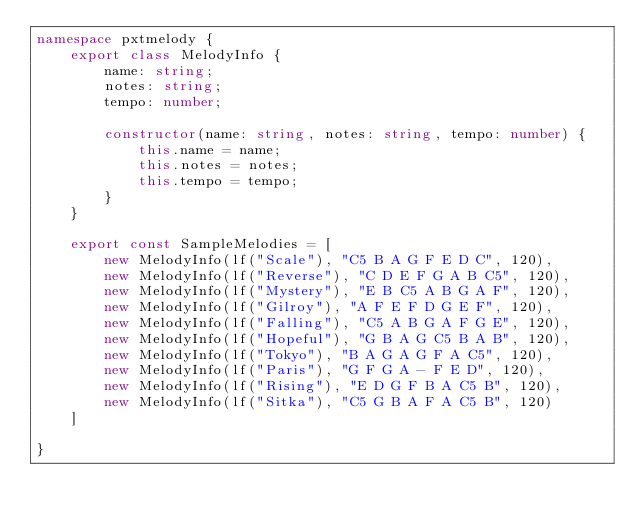<code> <loc_0><loc_0><loc_500><loc_500><_TypeScript_>namespace pxtmelody {
    export class MelodyInfo {
        name: string;
        notes: string;
        tempo: number;

        constructor(name: string, notes: string, tempo: number) {
            this.name = name;
            this.notes = notes;
            this.tempo = tempo;
        }
    }

    export const SampleMelodies = [
        new MelodyInfo(lf("Scale"), "C5 B A G F E D C", 120),
        new MelodyInfo(lf("Reverse"), "C D E F G A B C5", 120),
        new MelodyInfo(lf("Mystery"), "E B C5 A B G A F", 120),
        new MelodyInfo(lf("Gilroy"), "A F E F D G E F", 120),
        new MelodyInfo(lf("Falling"), "C5 A B G A F G E", 120),
        new MelodyInfo(lf("Hopeful"), "G B A G C5 B A B", 120),
        new MelodyInfo(lf("Tokyo"), "B A G A G F A C5", 120),
        new MelodyInfo(lf("Paris"), "G F G A - F E D", 120),
        new MelodyInfo(lf("Rising"), "E D G F B A C5 B", 120),
        new MelodyInfo(lf("Sitka"), "C5 G B A F A C5 B", 120)
    ]

}
</code> 